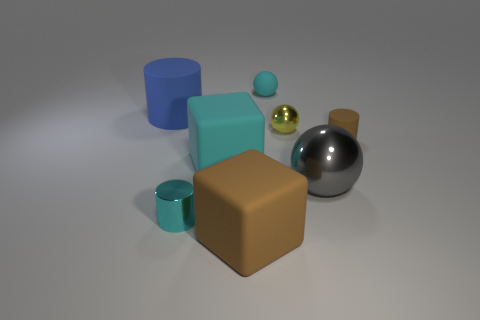Subtract all cyan cylinders. How many cylinders are left? 2 Subtract 2 cylinders. How many cylinders are left? 1 Subtract all green cylinders. Subtract all gray blocks. How many cylinders are left? 3 Subtract all green cylinders. How many brown blocks are left? 1 Subtract all blue cylinders. Subtract all gray metal spheres. How many objects are left? 6 Add 4 yellow metal balls. How many yellow metal balls are left? 5 Add 5 large things. How many large things exist? 9 Add 1 gray matte objects. How many objects exist? 9 Subtract all cyan cylinders. How many cylinders are left? 2 Subtract 0 red spheres. How many objects are left? 8 